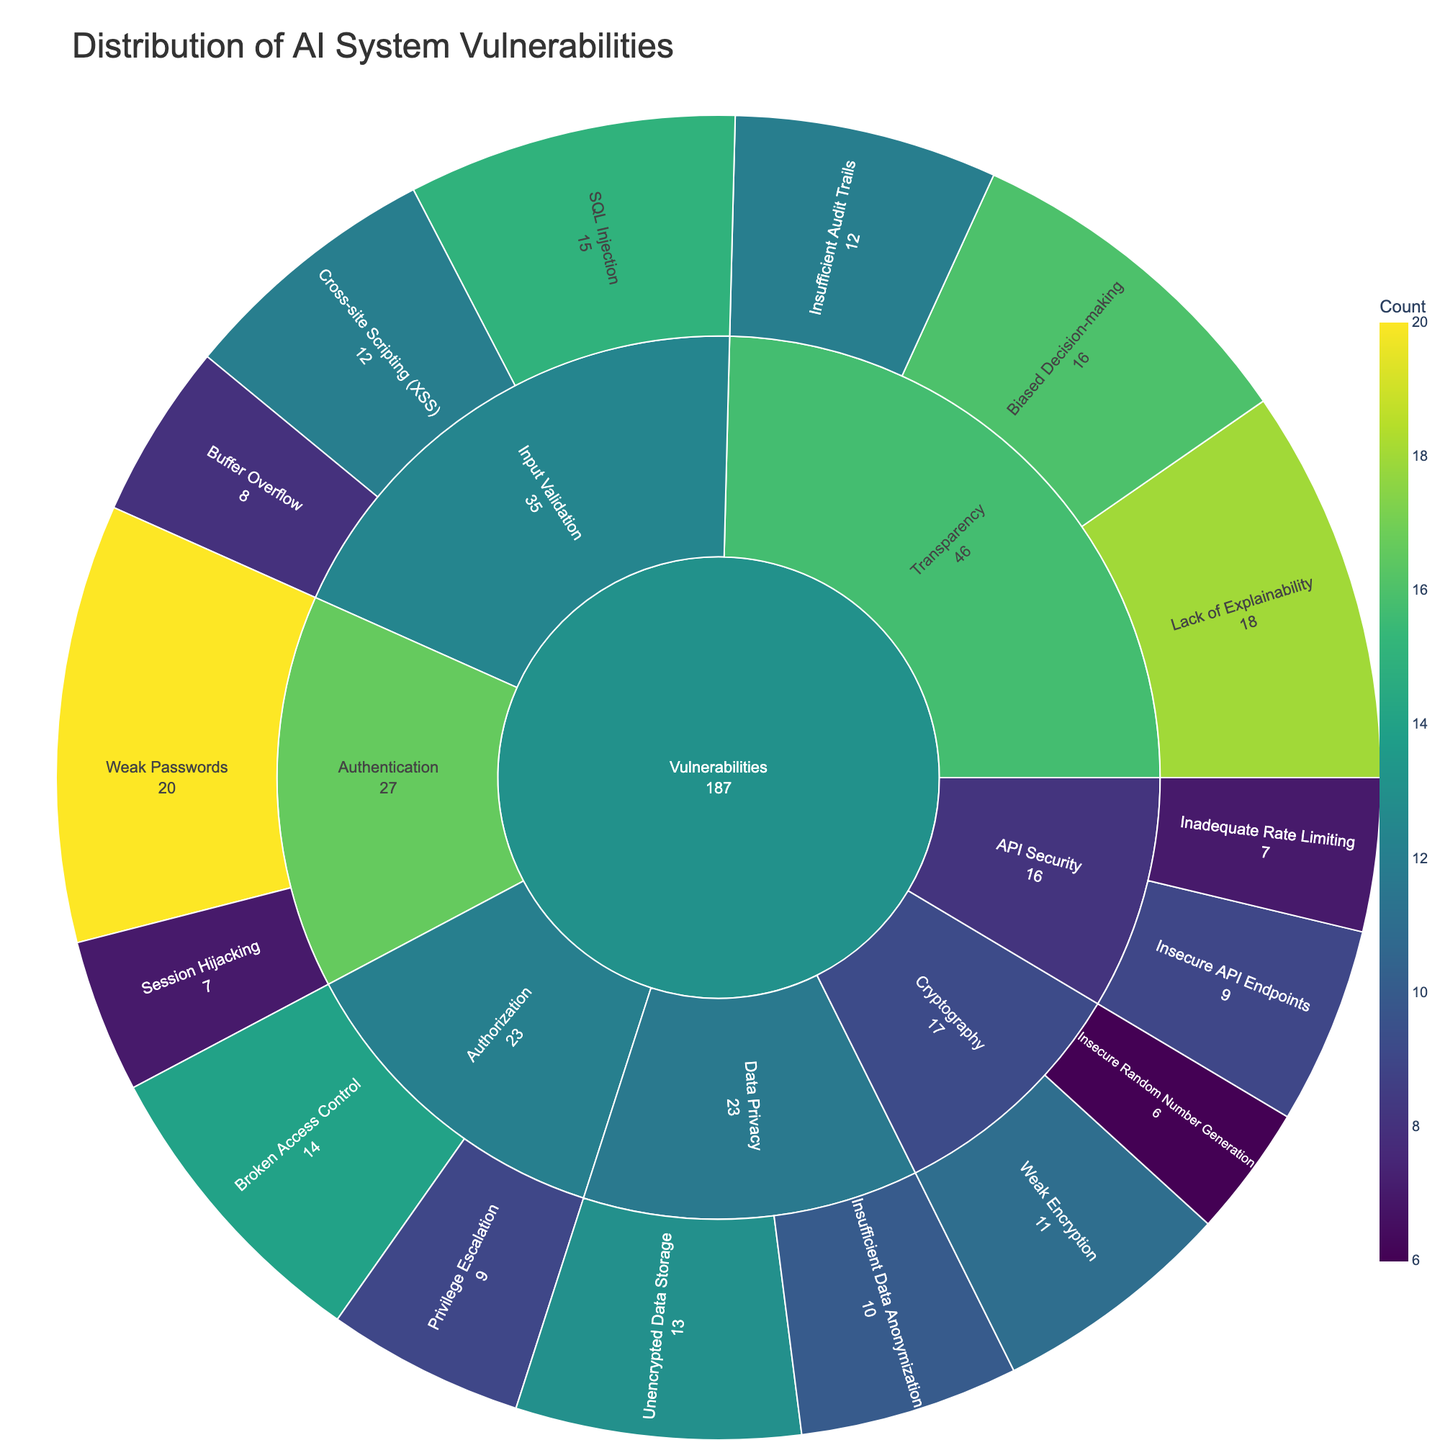What is the title of the sunburst chart? The title is located at the top of the figure and is typically the largest text in the chart.
Answer: Distribution of AI System Vulnerabilities Which subcategory has the highest count under the Authentication category? Locate the Authentication category in the chart and find the subcategory with the highest value.
Answer: Weak Passwords What is the total count of vulnerabilities in the Input Validation subcategory? Sum the values of all types under the Input Validation subcategory. This includes SQL Injection, Cross-site Scripting (XSS), and Buffer Overflow. 15 + 12 + 8 = 35.
Answer: 35 How does Lack of Explainability compare to Biased Decision-making in terms of count? Locate both Lack of Explainability and Biased Decision-making under the Transparency subcategory. Compare their counts directly.
Answer: Lack of Explainability has 18, Biased Decision-making has 16 Which subcategory has types with the least vulnerabilities overall? Identify the subcategory with the smallest total count by adding up the counts of all types within each subcategory. Compare all the sums. The smallest belongs to API Security with counts: 9 (Insecure API Endpoints) + 7 (Inadequate Rate Limiting) = 16
Answer: API Security What is the average number of vulnerabilities for the types in the Cryptography subcategory? Sum the values under Cryptography and divide by the number of types. (11 + 6) / 2 = 8.5
Answer: 8.5 How significant is the vulnerability related to Insecure Random Number Generation compared to all other vulnerabilities within Cryptography? Compare the count of Insecure Random Number Generation to the sum of counts in its subcategory. Insecure Random Number Generation has 6, total in Cryptography is 17. 6/17 = roughly 35.3%.
Answer: Approximately 35.3% Which categories have more vulnerabilities: Authorization or Data Privacy? Sum the values for Authorization (Broken Access Control + Privilege Escalation = 14 + 9 = 23) and Data Privacy (Unencrypted Data Storage + Insufficient Data Anonymization = 13 + 10 = 23). Both have the same total.
Answer: Equal (23 each) How does the count of Insufficient Data Anonymization compare to Insecure API Endpoints? Locate Insufficient Data Anonymization and Insecure API Endpoints. Compare their counts directly.
Answer: Insufficient Data Anonymization has 10, Insecure API Endpoints has 9 What is the total number of vulnerabilities across all categories? Sum all the counts in the entire figure. 15 (SQL Injection) + 12 (XSS) + 8 (Buffer Overflow) + 20 (Weak Passwords) + 7 (Session Hijacking) + 14 (Broken Access Control) + 9 (Privilege Escalation) + 11 (Weak Encryption) + 6 (Insecure Random Number Generation) + 13 (Unencrypted Data Storage) + 10 (Insufficient Data Anonymization) + 18 (Lack of Explainability) + 16 (Biased Decision-making) + 12 (Insufficient Audit Trails) + 9 (Insecure API Endpoints) + 7 (Inadequate Rate Limiting) = 187
Answer: 187 